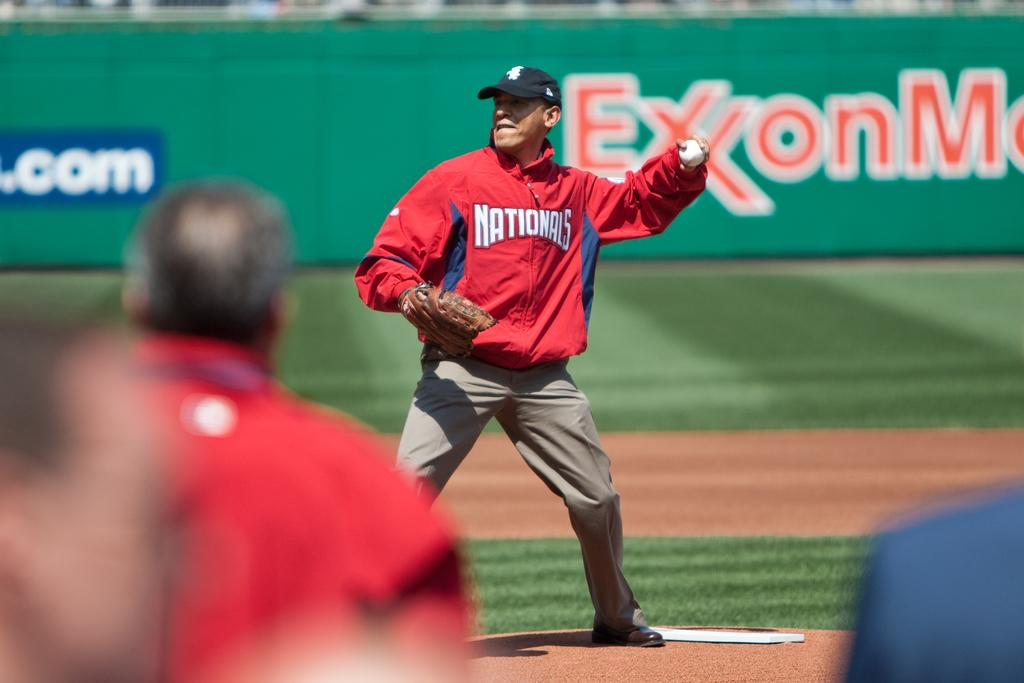<image>
Relay a brief, clear account of the picture shown. Man wearing a jacket that says Nationals pitching a ball. 